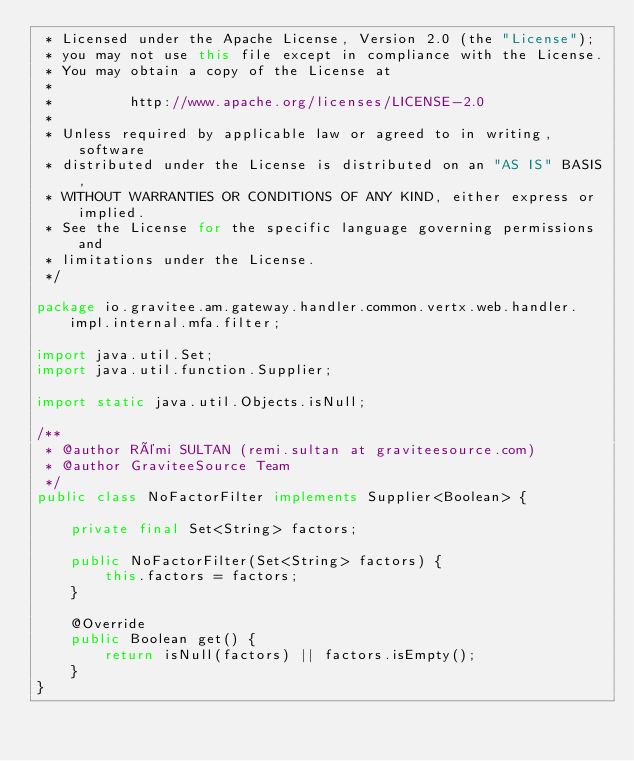Convert code to text. <code><loc_0><loc_0><loc_500><loc_500><_Java_> * Licensed under the Apache License, Version 2.0 (the "License");
 * you may not use this file except in compliance with the License.
 * You may obtain a copy of the License at
 *
 *         http://www.apache.org/licenses/LICENSE-2.0
 *
 * Unless required by applicable law or agreed to in writing, software
 * distributed under the License is distributed on an "AS IS" BASIS,
 * WITHOUT WARRANTIES OR CONDITIONS OF ANY KIND, either express or implied.
 * See the License for the specific language governing permissions and
 * limitations under the License.
 */

package io.gravitee.am.gateway.handler.common.vertx.web.handler.impl.internal.mfa.filter;

import java.util.Set;
import java.util.function.Supplier;

import static java.util.Objects.isNull;

/**
 * @author Rémi SULTAN (remi.sultan at graviteesource.com)
 * @author GraviteeSource Team
 */
public class NoFactorFilter implements Supplier<Boolean> {

    private final Set<String> factors;

    public NoFactorFilter(Set<String> factors) {
        this.factors = factors;
    }

    @Override
    public Boolean get() {
        return isNull(factors) || factors.isEmpty();
    }
}
</code> 